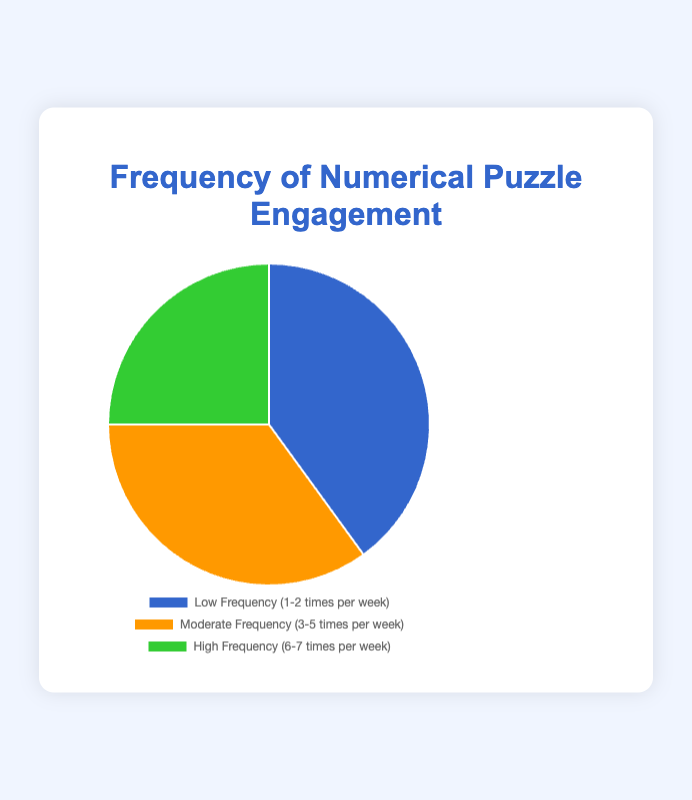What percentage of respondents engage in numerical puzzles with low frequency? This question requires identifying the segment labeled "Low Frequency (1-2 times per week)" on the pie chart and reading off the corresponding percentage.
Answer: 40% How much higher is the percentage of respondents with low frequency compared to high frequency? Subtract the percentage of the "High Frequency (6-7 times per week)" (25%) from the "Low Frequency" (40%): 40% - 25% = 15%.
Answer: 15% Which frequency category has the lowest percentage of engagement? Look for the smallest segment on the pie chart. The "High Frequency (6-7 times per week)" has the lowest percentage.
Answer: High Frequency What is the combined percentage of respondents with moderate and high frequency engagement? Add the percentages of "Moderate Frequency (3-5 times per week)" (35%) and "High Frequency (6-7 times per week)" (25%): 35% + 25% = 60%.
Answer: 60% What is the average percentage of respondents across all three frequency categories? Add all percentages (40%, 35%, 25%) and then divide by 3: (40% + 35% + 25%) / 3 = 100% / 3 ≈ 33.33%.
Answer: 33.33% Is the percentage difference between low and moderate frequency greater than the difference between moderate and high frequency? Calculate both differences: 40% - 35% = 5% (low to moderate) and 35% - 25% = 10% (moderate to high). Compare these differences: 5% < 10%, so the difference between moderate and high is greater.
Answer: No If 1000 participants were surveyed, how many of them engaged in numerical puzzles with high frequency? Multiply the total number of participants (1000) by the percentage for high frequency (25%): 1000 * 25% = 250 participants.
Answer: 250 Which color represents the highest engagement frequency in the pie chart? Identify the segment with the highest percentage and note its color. The "Low Frequency (1-2 times per week)" segment is blue, which represents the highest engagement frequency.
Answer: Blue 